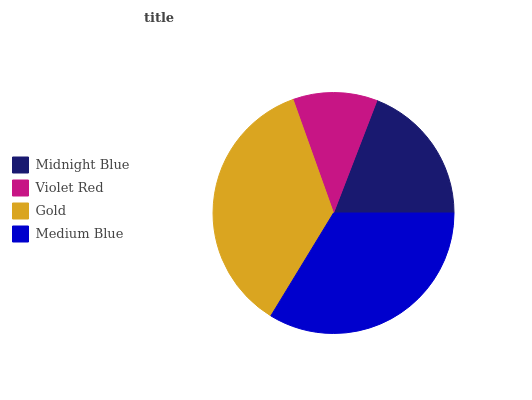Is Violet Red the minimum?
Answer yes or no. Yes. Is Gold the maximum?
Answer yes or no. Yes. Is Gold the minimum?
Answer yes or no. No. Is Violet Red the maximum?
Answer yes or no. No. Is Gold greater than Violet Red?
Answer yes or no. Yes. Is Violet Red less than Gold?
Answer yes or no. Yes. Is Violet Red greater than Gold?
Answer yes or no. No. Is Gold less than Violet Red?
Answer yes or no. No. Is Medium Blue the high median?
Answer yes or no. Yes. Is Midnight Blue the low median?
Answer yes or no. Yes. Is Violet Red the high median?
Answer yes or no. No. Is Gold the low median?
Answer yes or no. No. 